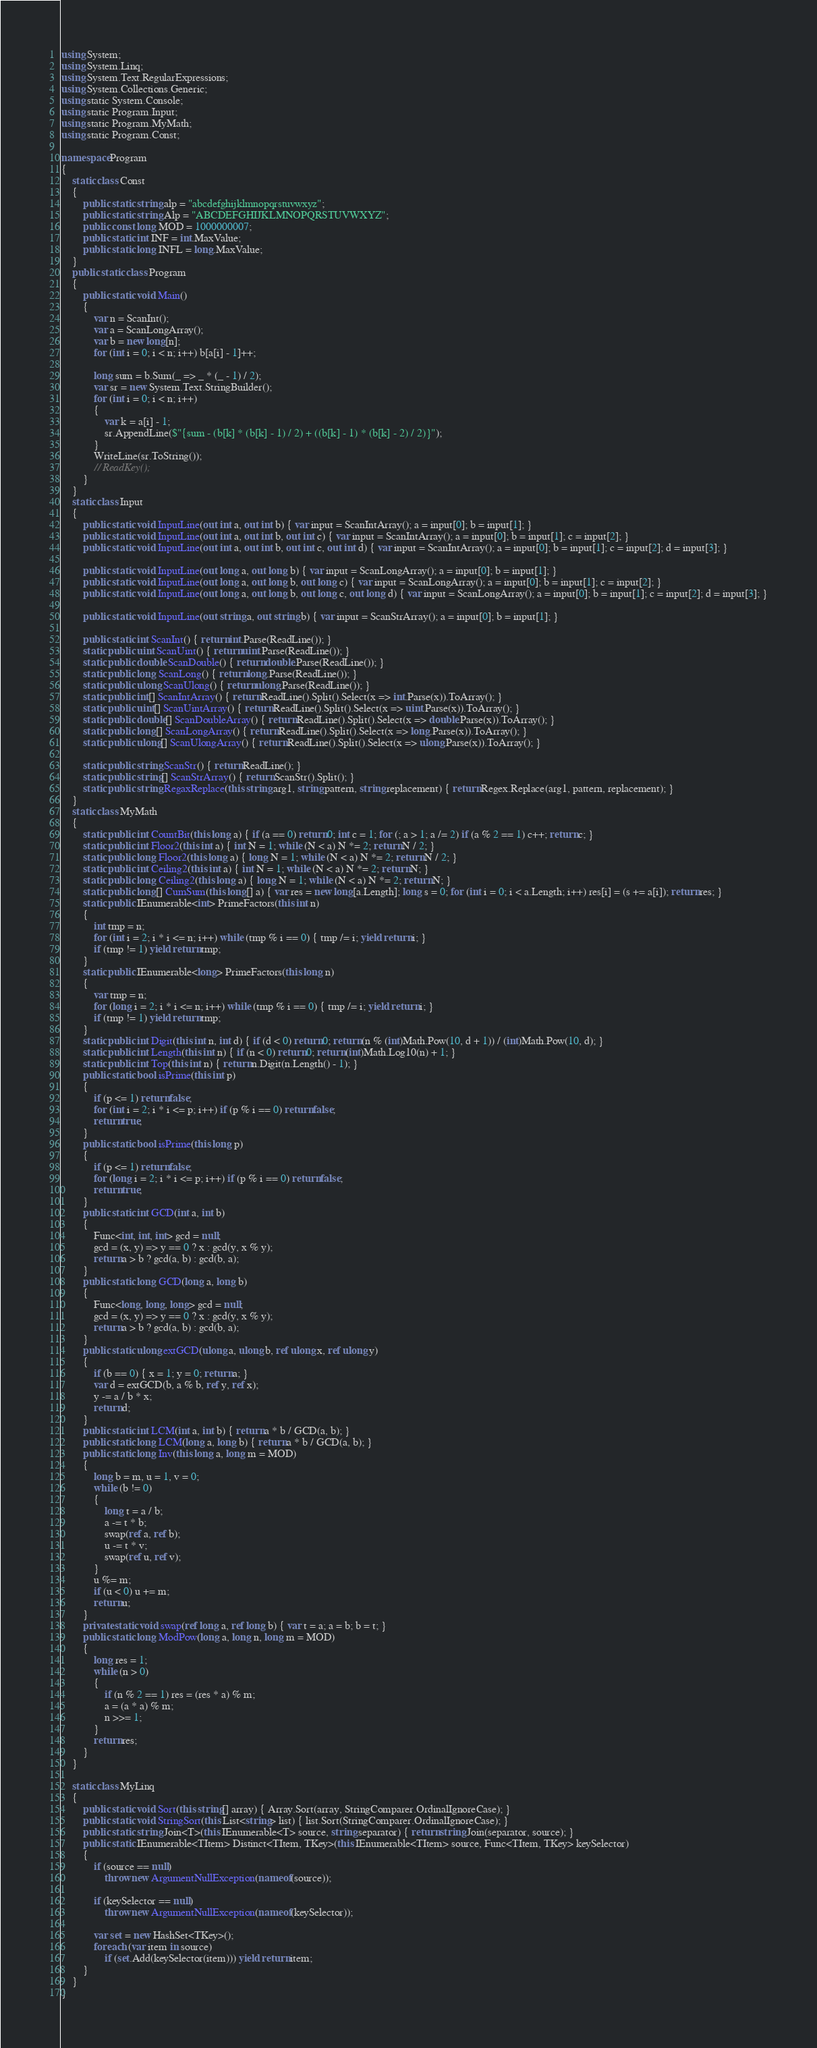Convert code to text. <code><loc_0><loc_0><loc_500><loc_500><_C#_>using System;
using System.Linq;
using System.Text.RegularExpressions;
using System.Collections.Generic;
using static System.Console;
using static Program.Input;
using static Program.MyMath;
using static Program.Const;

namespace Program
{
    static class Const
    {
        public static string alp = "abcdefghijklmnopqrstuvwxyz";
        public static string Alp = "ABCDEFGHIJKLMNOPQRSTUVWXYZ";
        public const long MOD = 1000000007;
        public static int INF = int.MaxValue;
        public static long INFL = long.MaxValue;
    }
    public static class Program
    {
        public static void Main()
        {
            var n = ScanInt();
            var a = ScanLongArray();
            var b = new long[n];
            for (int i = 0; i < n; i++) b[a[i] - 1]++;

            long sum = b.Sum(_ => _ * (_ - 1) / 2);
            var sr = new System.Text.StringBuilder();
            for (int i = 0; i < n; i++)
            {
                var k = a[i] - 1;
                sr.AppendLine($"{sum - (b[k] * (b[k] - 1) / 2) + ((b[k] - 1) * (b[k] - 2) / 2)}");
            }
            WriteLine(sr.ToString());
            // ReadKey();
        }
    }
    static class Input
    {
        public static void InputLine(out int a, out int b) { var input = ScanIntArray(); a = input[0]; b = input[1]; }
        public static void InputLine(out int a, out int b, out int c) { var input = ScanIntArray(); a = input[0]; b = input[1]; c = input[2]; }
        public static void InputLine(out int a, out int b, out int c, out int d) { var input = ScanIntArray(); a = input[0]; b = input[1]; c = input[2]; d = input[3]; }

        public static void InputLine(out long a, out long b) { var input = ScanLongArray(); a = input[0]; b = input[1]; }
        public static void InputLine(out long a, out long b, out long c) { var input = ScanLongArray(); a = input[0]; b = input[1]; c = input[2]; }
        public static void InputLine(out long a, out long b, out long c, out long d) { var input = ScanLongArray(); a = input[0]; b = input[1]; c = input[2]; d = input[3]; }

        public static void InputLine(out string a, out string b) { var input = ScanStrArray(); a = input[0]; b = input[1]; }

        public static int ScanInt() { return int.Parse(ReadLine()); }
        static public uint ScanUint() { return uint.Parse(ReadLine()); }
        static public double ScanDouble() { return double.Parse(ReadLine()); }
        static public long ScanLong() { return long.Parse(ReadLine()); }
        static public ulong ScanUlong() { return ulong.Parse(ReadLine()); }
        static public int[] ScanIntArray() { return ReadLine().Split().Select(x => int.Parse(x)).ToArray(); }
        static public uint[] ScanUintArray() { return ReadLine().Split().Select(x => uint.Parse(x)).ToArray(); }
        static public double[] ScanDoubleArray() { return ReadLine().Split().Select(x => double.Parse(x)).ToArray(); }
        static public long[] ScanLongArray() { return ReadLine().Split().Select(x => long.Parse(x)).ToArray(); }
        static public ulong[] ScanUlongArray() { return ReadLine().Split().Select(x => ulong.Parse(x)).ToArray(); }

        static public string ScanStr() { return ReadLine(); }
        static public string[] ScanStrArray() { return ScanStr().Split(); }
        static public string RegaxReplace(this string arg1, string pattern, string replacement) { return Regex.Replace(arg1, pattern, replacement); }
    }
    static class MyMath
    {
        static public int CountBit(this long a) { if (a == 0) return 0; int c = 1; for (; a > 1; a /= 2) if (a % 2 == 1) c++; return c; }
        static public int Floor2(this int a) { int N = 1; while (N < a) N *= 2; return N / 2; }
        static public long Floor2(this long a) { long N = 1; while (N < a) N *= 2; return N / 2; }
        static public int Ceiling2(this int a) { int N = 1; while (N < a) N *= 2; return N; }
        static public long Ceiling2(this long a) { long N = 1; while (N < a) N *= 2; return N; }
        static public long[] CumSum(this long[] a) { var res = new long[a.Length]; long s = 0; for (int i = 0; i < a.Length; i++) res[i] = (s += a[i]); return res; }
        static public IEnumerable<int> PrimeFactors(this int n)
        {
            int tmp = n;
            for (int i = 2; i * i <= n; i++) while (tmp % i == 0) { tmp /= i; yield return i; }
            if (tmp != 1) yield return tmp;
        }
        static public IEnumerable<long> PrimeFactors(this long n)
        {
            var tmp = n;
            for (long i = 2; i * i <= n; i++) while (tmp % i == 0) { tmp /= i; yield return i; }
            if (tmp != 1) yield return tmp;
        }
        static public int Digit(this int n, int d) { if (d < 0) return 0; return (n % (int)Math.Pow(10, d + 1)) / (int)Math.Pow(10, d); }
        static public int Length(this int n) { if (n < 0) return 0; return (int)Math.Log10(n) + 1; }
        static public int Top(this int n) { return n.Digit(n.Length() - 1); }
        public static bool isPrime(this int p)
        {
            if (p <= 1) return false;
            for (int i = 2; i * i <= p; i++) if (p % i == 0) return false;
            return true;
        }
        public static bool isPrime(this long p)
        {
            if (p <= 1) return false;
            for (long i = 2; i * i <= p; i++) if (p % i == 0) return false;
            return true;
        }
        public static int GCD(int a, int b)
        {
            Func<int, int, int> gcd = null;
            gcd = (x, y) => y == 0 ? x : gcd(y, x % y);
            return a > b ? gcd(a, b) : gcd(b, a);
        }
        public static long GCD(long a, long b)
        {
            Func<long, long, long> gcd = null;
            gcd = (x, y) => y == 0 ? x : gcd(y, x % y);
            return a > b ? gcd(a, b) : gcd(b, a);
        }
        public static ulong extGCD(ulong a, ulong b, ref ulong x, ref ulong y)
        {
            if (b == 0) { x = 1; y = 0; return a; }
            var d = extGCD(b, a % b, ref y, ref x);
            y -= a / b * x;
            return d;
        }
        public static int LCM(int a, int b) { return a * b / GCD(a, b); }
        public static long LCM(long a, long b) { return a * b / GCD(a, b); }
        public static long Inv(this long a, long m = MOD)
        {
            long b = m, u = 1, v = 0;
            while (b != 0)
            {
                long t = a / b;
                a -= t * b;
                swap(ref a, ref b);
                u -= t * v;
                swap(ref u, ref v);
            }
            u %= m;
            if (u < 0) u += m;
            return u;
        }
        private static void swap(ref long a, ref long b) { var t = a; a = b; b = t; }
        public static long ModPow(long a, long n, long m = MOD)
        {
            long res = 1;
            while (n > 0)
            {
                if (n % 2 == 1) res = (res * a) % m;
                a = (a * a) % m;
                n >>= 1;
            }
            return res;
        }
    }

    static class MyLinq
    {
        public static void Sort(this string[] array) { Array.Sort(array, StringComparer.OrdinalIgnoreCase); }
        public static void StringSort(this List<string> list) { list.Sort(StringComparer.OrdinalIgnoreCase); }
        public static string Join<T>(this IEnumerable<T> source, string separator) { return string.Join(separator, source); }
        public static IEnumerable<TItem> Distinct<TItem, TKey>(this IEnumerable<TItem> source, Func<TItem, TKey> keySelector)
        {
            if (source == null)
                throw new ArgumentNullException(nameof(source));

            if (keySelector == null)
                throw new ArgumentNullException(nameof(keySelector));

            var set = new HashSet<TKey>();
            foreach (var item in source)
                if (set.Add(keySelector(item))) yield return item;
        }
    }
}
</code> 